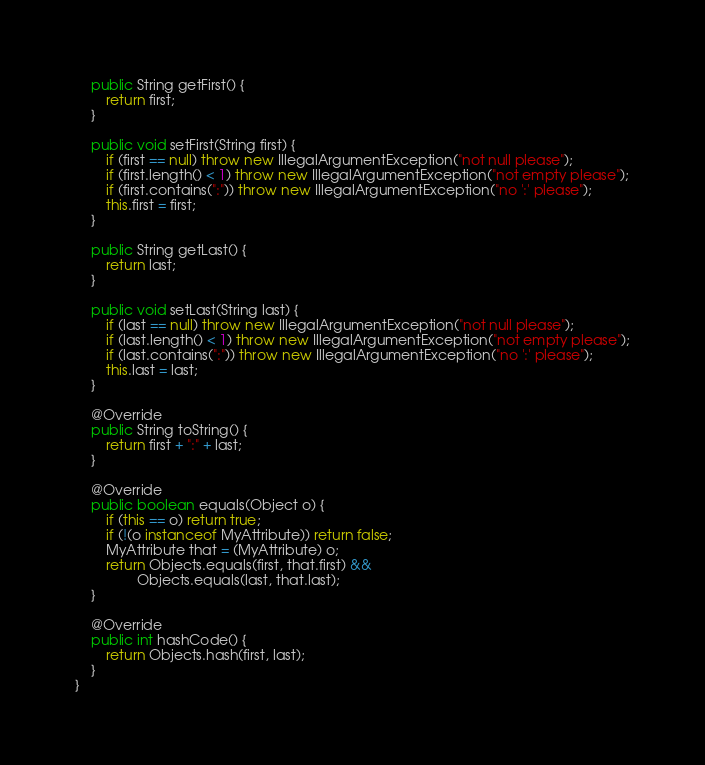Convert code to text. <code><loc_0><loc_0><loc_500><loc_500><_Java_>
    public String getFirst() {
        return first;
    }

    public void setFirst(String first) {
        if (first == null) throw new IllegalArgumentException("not null please");
        if (first.length() < 1) throw new IllegalArgumentException("not empty please");
        if (first.contains(":")) throw new IllegalArgumentException("no ':' please");
        this.first = first;
    }

    public String getLast() {
        return last;
    }

    public void setLast(String last) {
        if (last == null) throw new IllegalArgumentException("not null please");
        if (last.length() < 1) throw new IllegalArgumentException("not empty please");
        if (last.contains(":")) throw new IllegalArgumentException("no ':' please");
        this.last = last;
    }

    @Override
    public String toString() {
        return first + ":" + last;
    }

    @Override
    public boolean equals(Object o) {
        if (this == o) return true;
        if (!(o instanceof MyAttribute)) return false;
        MyAttribute that = (MyAttribute) o;
        return Objects.equals(first, that.first) &&
                Objects.equals(last, that.last);
    }

    @Override
    public int hashCode() {
        return Objects.hash(first, last);
    }
}
</code> 